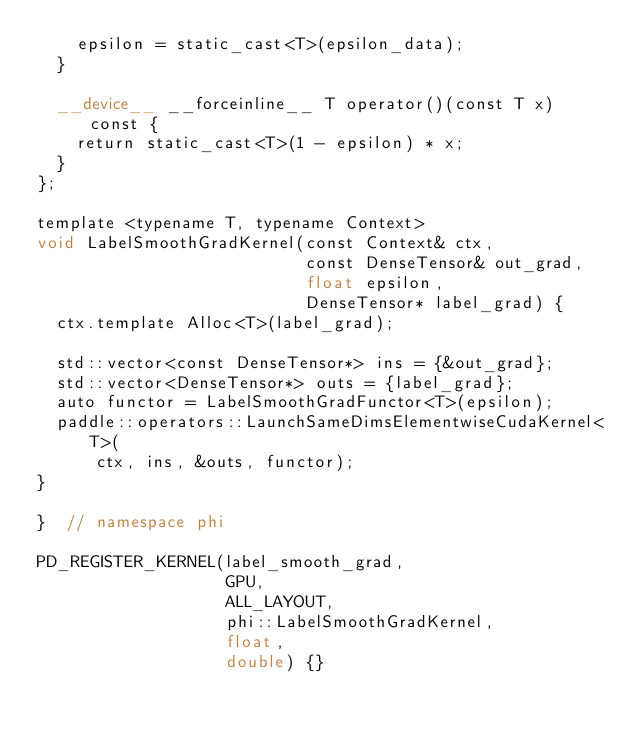Convert code to text. <code><loc_0><loc_0><loc_500><loc_500><_Cuda_>    epsilon = static_cast<T>(epsilon_data);
  }

  __device__ __forceinline__ T operator()(const T x) const {
    return static_cast<T>(1 - epsilon) * x;
  }
};

template <typename T, typename Context>
void LabelSmoothGradKernel(const Context& ctx,
                           const DenseTensor& out_grad,
                           float epsilon,
                           DenseTensor* label_grad) {
  ctx.template Alloc<T>(label_grad);

  std::vector<const DenseTensor*> ins = {&out_grad};
  std::vector<DenseTensor*> outs = {label_grad};
  auto functor = LabelSmoothGradFunctor<T>(epsilon);
  paddle::operators::LaunchSameDimsElementwiseCudaKernel<T>(
      ctx, ins, &outs, functor);
}

}  // namespace phi

PD_REGISTER_KERNEL(label_smooth_grad,
                   GPU,
                   ALL_LAYOUT,
                   phi::LabelSmoothGradKernel,
                   float,
                   double) {}
</code> 